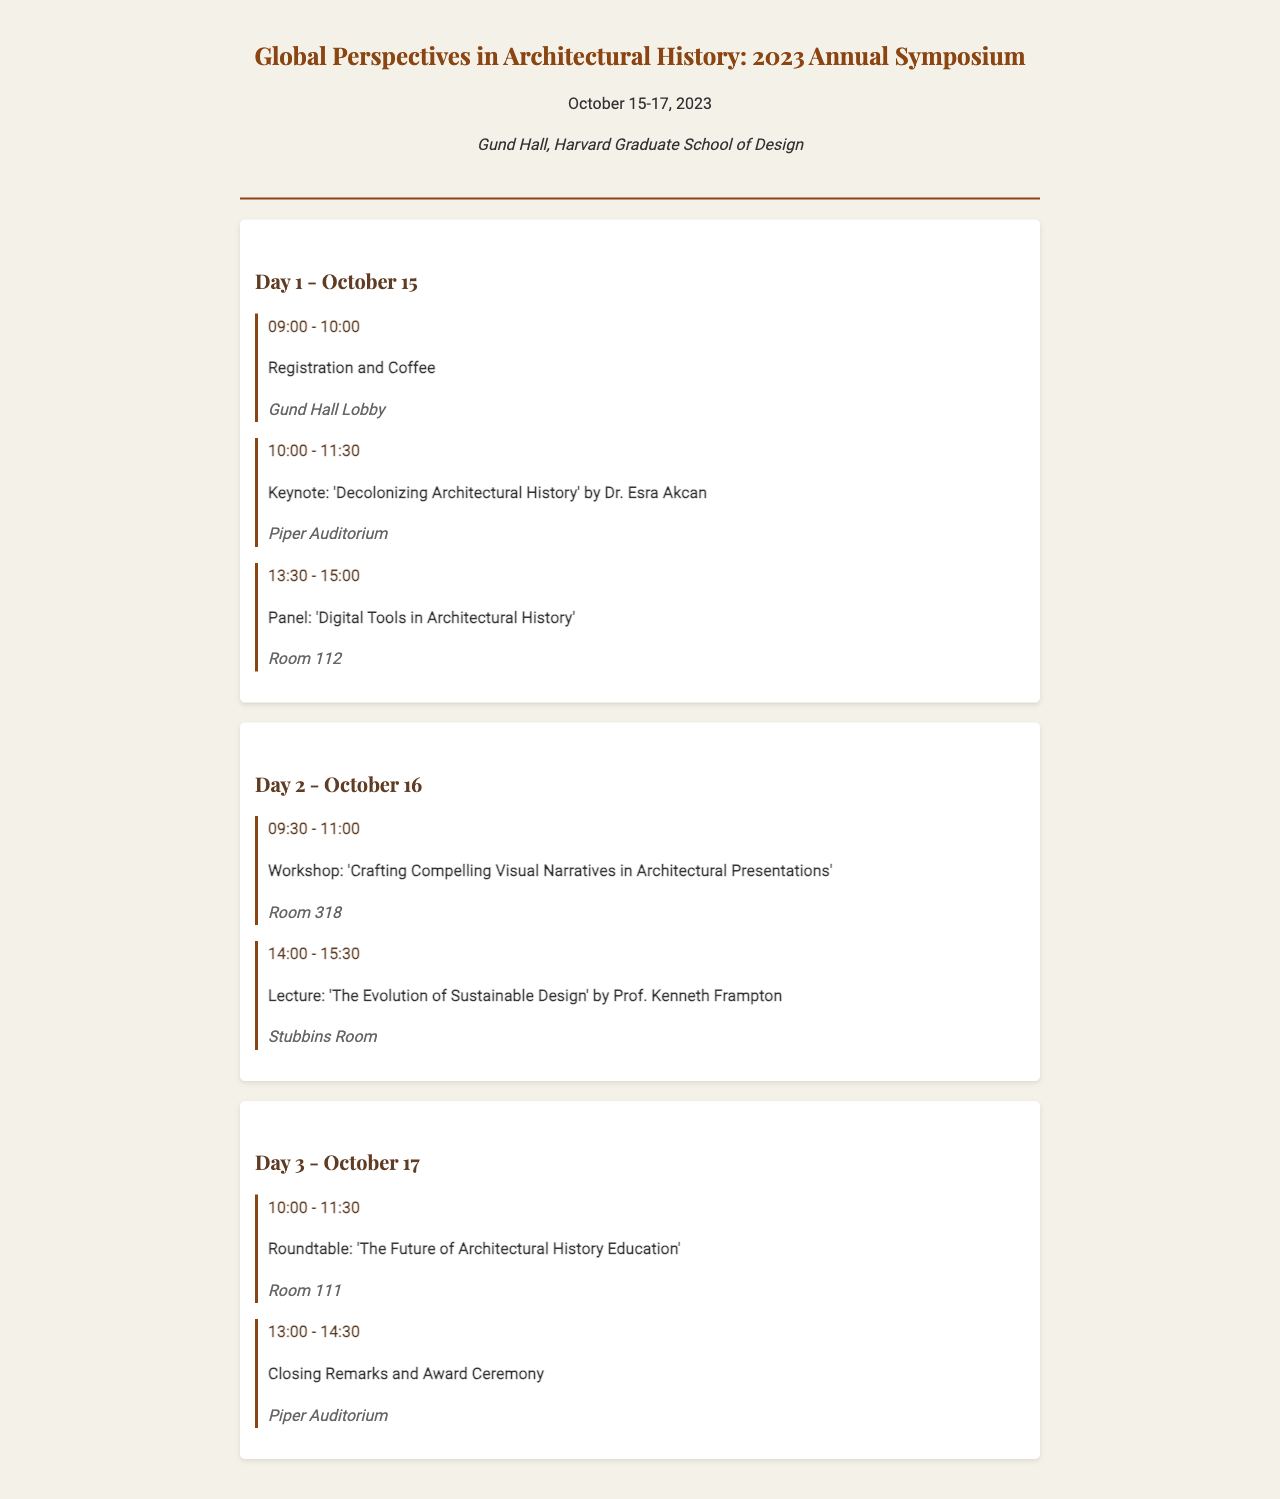What are the dates of the symposium? The symposium is scheduled to take place from October 15 to October 17, 2023.
Answer: October 15-17, 2023 Who is the keynote speaker? The keynote speaker for the event is Dr. Esra Akcan, as indicated in the schedule.
Answer: Dr. Esra Akcan What is the location for the registration? According to the schedule, the registration will take place in the Gund Hall Lobby.
Answer: Gund Hall Lobby What time does the roundtable start on Day 3? The roundtable on Day 3 is scheduled to begin at 10:00.
Answer: 10:00 Which room is the workshop held in on Day 2? The workshop is to be held in Room 318, as specified in the document.
Answer: Room 318 What is the title of the lecture by Prof. Kenneth Frampton? The title of the lecture is 'The Evolution of Sustainable Design,' as noted in the schedule.
Answer: The Evolution of Sustainable Design How long is the keynote session? The keynote session lasts for 1.5 hours, from 10:00 to 11:30.
Answer: 1.5 hours What is the venue for the closing remarks? The closing remarks and award ceremony will take place in the Piper Auditorium.
Answer: Piper Auditorium 